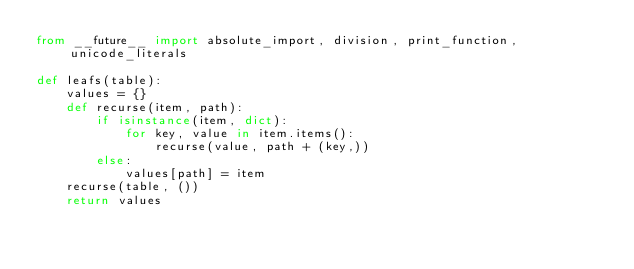Convert code to text. <code><loc_0><loc_0><loc_500><loc_500><_Python_>from __future__ import absolute_import, division, print_function, unicode_literals

def leafs(table):
    values = {}
    def recurse(item, path):
        if isinstance(item, dict):
            for key, value in item.items():
                recurse(value, path + (key,))
        else:
            values[path] = item
    recurse(table, ())
    return values
</code> 